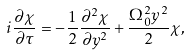Convert formula to latex. <formula><loc_0><loc_0><loc_500><loc_500>i \frac { \partial \chi } { \partial \tau } = - \frac { 1 } { 2 } \frac { \partial ^ { 2 } \chi } { \partial y ^ { 2 } } + \frac { \Omega _ { 0 } ^ { 2 } y ^ { 2 } } { 2 } \chi ,</formula> 